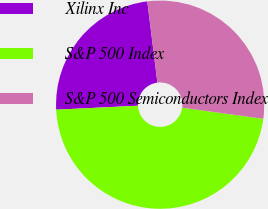Convert chart. <chart><loc_0><loc_0><loc_500><loc_500><pie_chart><fcel>Xilinx Inc<fcel>S&P 500 Index<fcel>S&P 500 Semiconductors Index<nl><fcel>23.79%<fcel>47.07%<fcel>29.14%<nl></chart> 